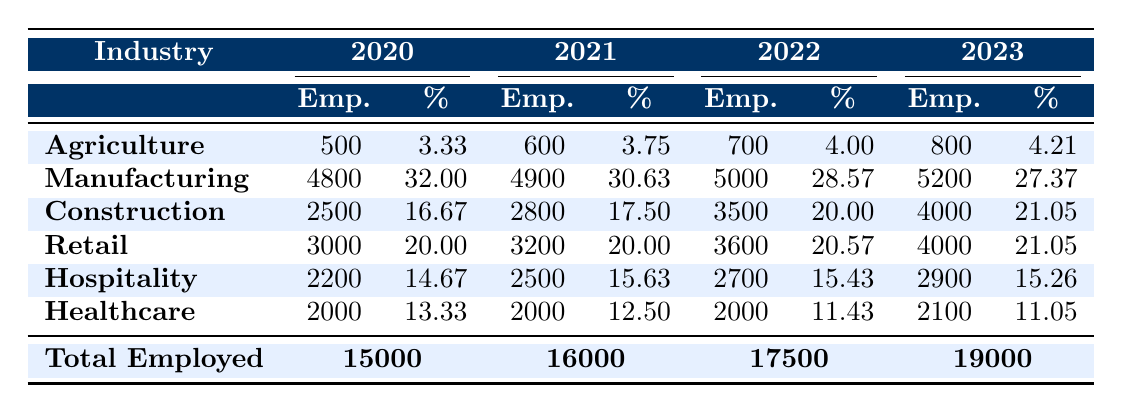What was the total number of Turkish immigrants employed in 2021? The table indicates that in 2021, the total number of employed Turkish immigrants was 16,000.
Answer: 16,000 In which year did the healthcare industry have the highest number of employees? By checking the table, the healthcare industry consistently employed 2,000 employees from 2020 to 2022, and in 2023 it increased to 2,100, which is the highest reported figure.
Answer: 2023 What percentage of total employment was in retail in 2022? According to the table, the retail industry employed 3,600 workers in 2022, which contributed to 20.57% of the total employment.
Answer: 20.57% Was there any increase in the number of employees in the construction industry from 2020 to 2023? The table shows that the number of employees in the construction industry increased from 2,500 in 2020 to 4,000 in 2023. Therefore, there was an increase.
Answer: Yes What was the overall growth in total employment from 2020 to 2023? From 2020 to 2023, total employment grew from 15,000 to 19,000. To find the growth, we calculate 19,000 - 15,000, which equals 4,000. Thus, the overall growth is 4,000 employees.
Answer: 4,000 Which industry had the highest number of employees in 2020, and what was that number? Referring to the table for 2020, manufacturing had the highest number of employees with 4,800.
Answer: Manufacturing; 4,800 What is the difference in the percentage of employees in the hospitality industry between 2020 and 2023? In 2020, the hospitality industry comprised 14.67% of total employment, while in 2023 it was 15.26%. The difference is calculated as 15.26% - 14.67% = 0.59%.
Answer: 0.59% How many more employees were in the agriculture industry in 2023 compared to 2020? The agriculture industry employed 800 employees in 2023 and 500 in 2020. The difference is 800 - 500 = 300 more employees in 2023.
Answer: 300 Did the total employment numbers increase every year from 2020 to 2023? The table confirms that total employment increased from 15,000 in 2020 to 16,000 in 2021, 17,500 in 2022, and 19,000 in 2023, so yes, it increased every year.
Answer: Yes What percentage of total employment in 2021 was attributed to the manufacturing industry? In 2021, the manufacturing industry had 4,900 employees, which was 30.63% of the total employment of 16,000. The percentage is directly provided in the table.
Answer: 30.63% Which year saw the lowest percentage of employment in healthcare, and what was that percentage? In 2022, the healthcare industry had the lowest percentage of 11.43%. Looking at the percentages in the table supports this conclusion.
Answer: 2022; 11.43% 